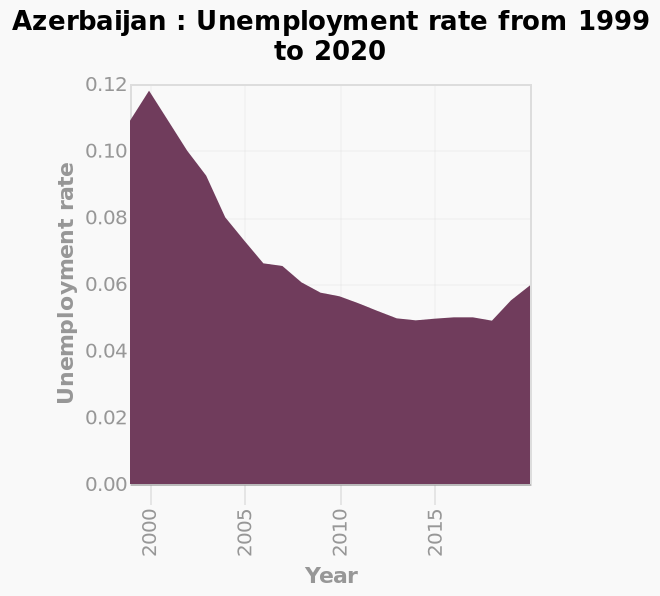<image>
please enumerates aspects of the construction of the chart This area graph is labeled Azerbaijan : Unemployment rate from 1999 to 2020. The x-axis shows Year using linear scale of range 2000 to 2015 while the y-axis plots Unemployment rate using linear scale with a minimum of 0.00 and a maximum of 0.12. What does the x-axis represent in this area graph?  The x-axis represents the year from 1999 to 2020. Offer a thorough analysis of the image. There has been a declining trend between 2000 and 2015, where the unemployment rate fell from 0.12 to 0.05 approximately. 